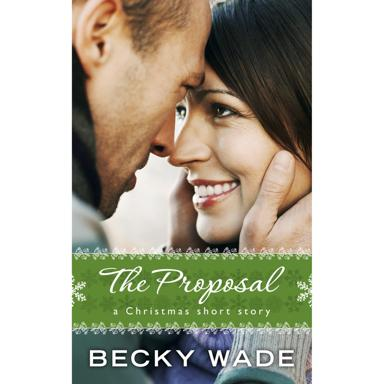Can you describe the emotions conveyed by the couple in the image? The couple's expression portrays a sentiment of profound affection and joy. Their eyes are locked in a warm gaze, indicative of a deep bond, perhaps suggesting a moment of significant connection or decision, as implied by the short story's title 'The Proposal.' The woman's slight smile and the man's gentle touch on her face amplify the tender and loving atmosphere between them. 